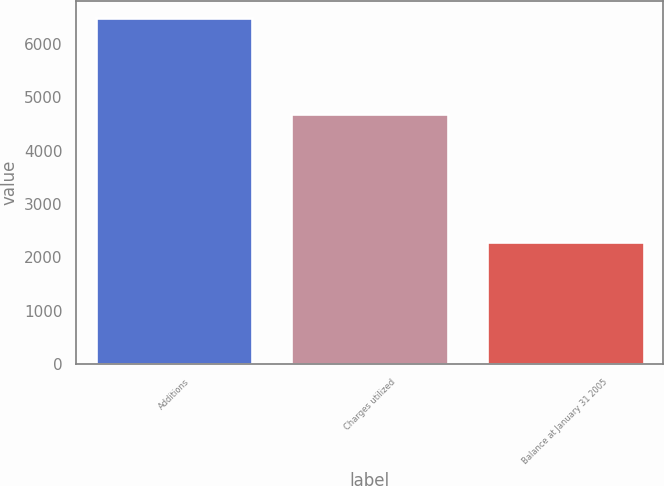<chart> <loc_0><loc_0><loc_500><loc_500><bar_chart><fcel>Additions<fcel>Charges utilized<fcel>Balance at January 31 2005<nl><fcel>6475<fcel>4679<fcel>2280<nl></chart> 